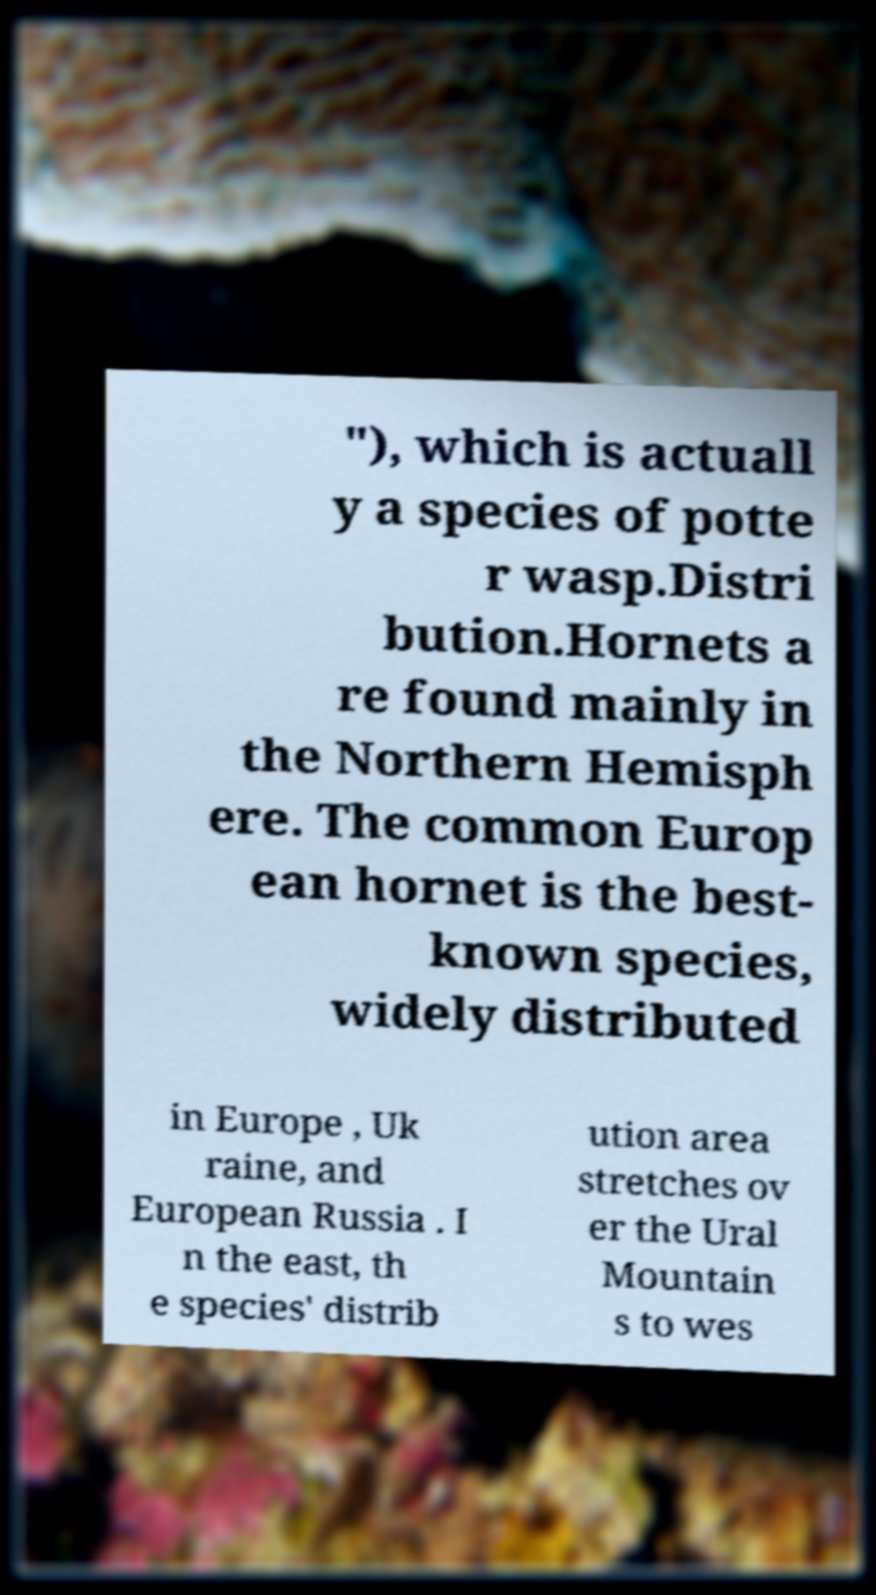What messages or text are displayed in this image? I need them in a readable, typed format. "), which is actuall y a species of potte r wasp.Distri bution.Hornets a re found mainly in the Northern Hemisph ere. The common Europ ean hornet is the best- known species, widely distributed in Europe , Uk raine, and European Russia . I n the east, th e species' distrib ution area stretches ov er the Ural Mountain s to wes 